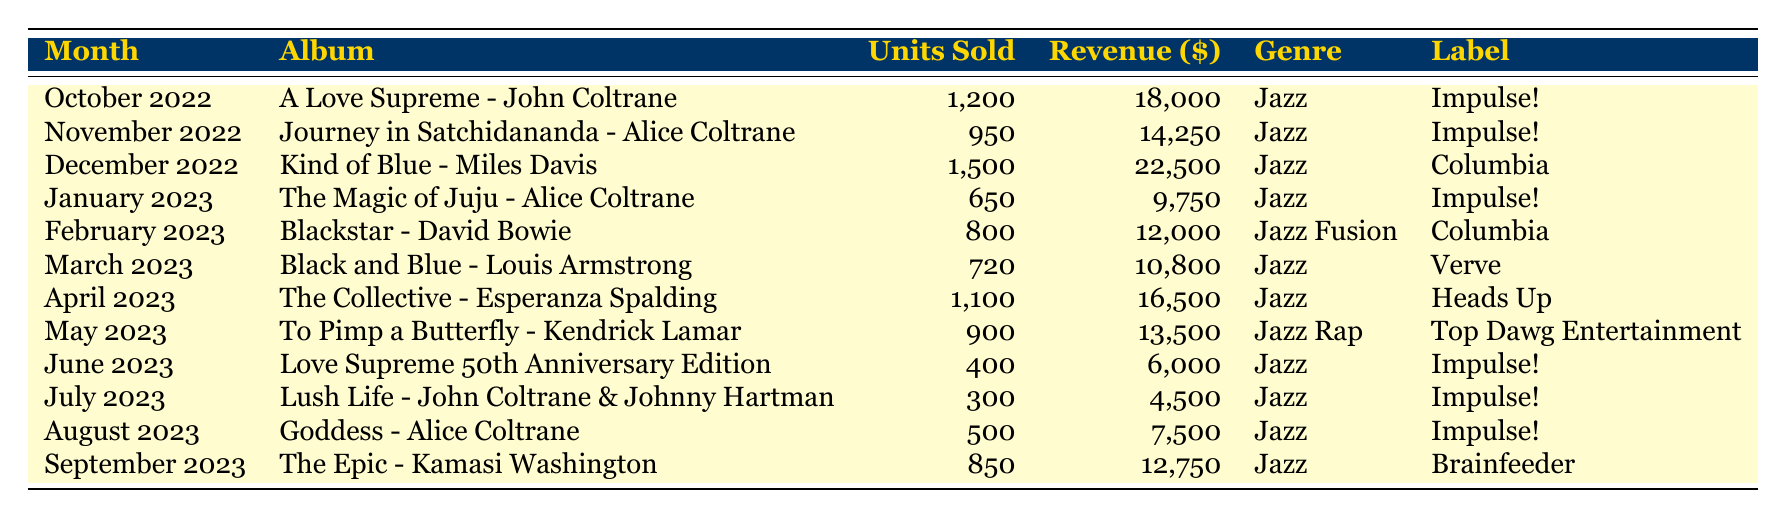What's the total number of albums sold in January 2023? The table shows that in January 2023, "The Magic of Juju - Alice Coltrane" sold 650 units. This is a specific retrieval question that looks for one piece of data.
Answer: 650 Which jazz album had the highest revenue in December 2022? The table shows that "Kind of Blue - Miles Davis" had the highest revenue of 22500 in December 2022, while other albums had lower revenue amounts.
Answer: Kind of Blue - Miles Davis Was "A Love Supreme - John Coltrane" the best-selling album overall? Looking through the table, "A Love Supreme - John Coltrane" sold 1200 units, which is high, but "Kind of Blue - Miles Davis" sold 1500 units. Therefore, it's false that it was the best-selling album.
Answer: No What is the total revenue generated from Alice Coltrane’s albums listed in the table? There are two albums by Alice Coltrane: "Journey in Satchidananda" generating 14250 and "The Magic of Juju" generating 9750. Summing them gives 14250 + 9750 = 24000. This is a compositional question that requires addition of multiple data points.
Answer: 24000 What was the average number of units sold across all albums listed? To find the average, first sum the units sold for all albums: 1200 + 950 + 1500 + 650 + 800 + 720 + 1100 + 900 + 400 + 300 + 500 + 850 = 10520. Then, divide by the number of albums, which is 12. So the average is 10520/12 ≈ 876.67. This is a more complex reasoning question requiring multiple calculations.
Answer: 876.67 Which month had the lowest album sales? By examining the table, July 2023 had the lowest sales with only 300 units sold for "Lush Life - John Coltrane & Johnny Hartman." This is a straightforward retrieval question.
Answer: July 2023 Did any album by Alice Coltrane sell more than 1000 units? In the table, we can see that "Journey in Satchidananda" sold 950 units, and "The Magic of Juju" sold 650 units, which means neither exceeded 1000 units, making this a factual-based question.
Answer: No What genre had the highest total revenue in the data set? To determine this, we need to calculate the total revenue for each genre. Jazz totals: 18000 + 14250 + 22500 + 10800 + 16500 + 4500 + 7500 + 12750 = 122800. Jazz Fusion: 12000, Jazz Rap: 13500. The total for Jazz is highest at 122800. This is a complex reasoning question requiring aggregation of multiple rows.
Answer: Jazz 